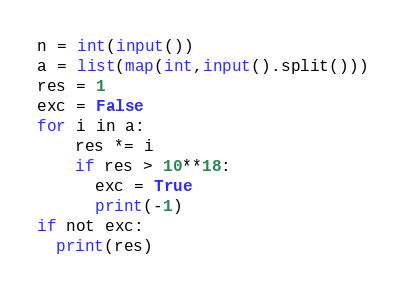<code> <loc_0><loc_0><loc_500><loc_500><_Python_>n = int(input())
a = list(map(int,input().split()))
res = 1
exc = False
for i in a:
	res *= i
	if res > 10**18:
      exc = True
      print(-1)
if not exc:
  print(res)</code> 